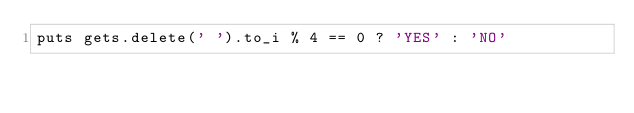Convert code to text. <code><loc_0><loc_0><loc_500><loc_500><_Ruby_>puts gets.delete(' ').to_i % 4 == 0 ? 'YES' : 'NO'</code> 